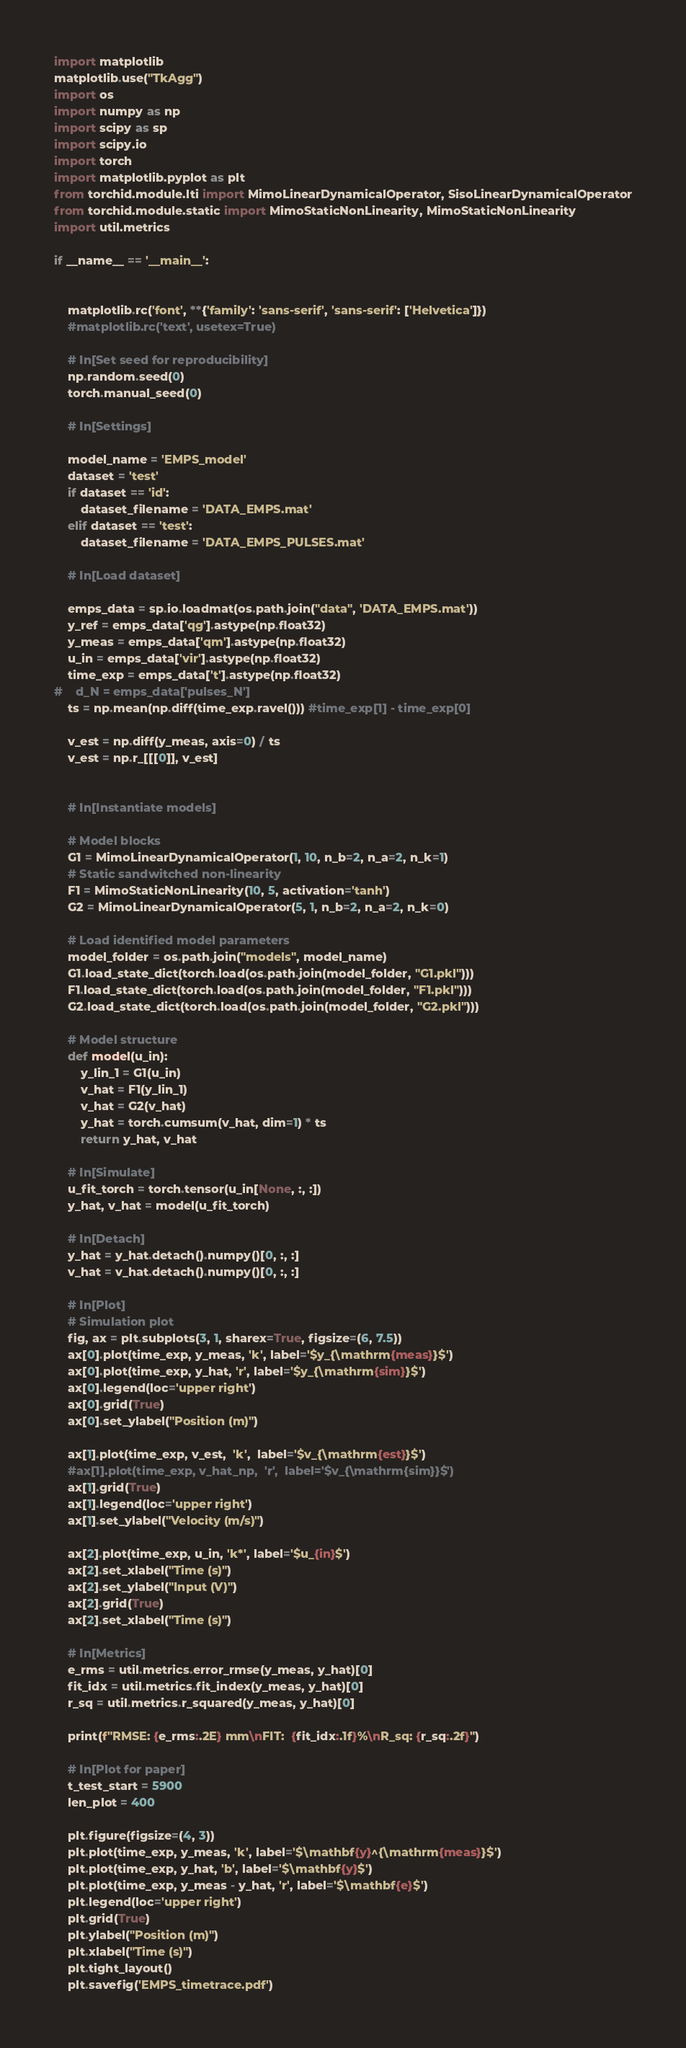Convert code to text. <code><loc_0><loc_0><loc_500><loc_500><_Python_>import matplotlib
matplotlib.use("TkAgg")
import os
import numpy as np
import scipy as sp
import scipy.io
import torch
import matplotlib.pyplot as plt
from torchid.module.lti import MimoLinearDynamicalOperator, SisoLinearDynamicalOperator
from torchid.module.static import MimoStaticNonLinearity, MimoStaticNonLinearity
import util.metrics

if __name__ == '__main__':


    matplotlib.rc('font', **{'family': 'sans-serif', 'sans-serif': ['Helvetica']})
    #matplotlib.rc('text', usetex=True)

    # In[Set seed for reproducibility]
    np.random.seed(0)
    torch.manual_seed(0)

    # In[Settings]

    model_name = 'EMPS_model'
    dataset = 'test'
    if dataset == 'id':
        dataset_filename = 'DATA_EMPS.mat'
    elif dataset == 'test':
        dataset_filename = 'DATA_EMPS_PULSES.mat'

    # In[Load dataset]

    emps_data = sp.io.loadmat(os.path.join("data", 'DATA_EMPS.mat'))
    y_ref = emps_data['qg'].astype(np.float32)
    y_meas = emps_data['qm'].astype(np.float32)
    u_in = emps_data['vir'].astype(np.float32)
    time_exp = emps_data['t'].astype(np.float32)
#    d_N = emps_data['pulses_N']
    ts = np.mean(np.diff(time_exp.ravel())) #time_exp[1] - time_exp[0]

    v_est = np.diff(y_meas, axis=0) / ts
    v_est = np.r_[[[0]], v_est]


    # In[Instantiate models]

    # Model blocks
    G1 = MimoLinearDynamicalOperator(1, 10, n_b=2, n_a=2, n_k=1)
    # Static sandwitched non-linearity
    F1 = MimoStaticNonLinearity(10, 5, activation='tanh')
    G2 = MimoLinearDynamicalOperator(5, 1, n_b=2, n_a=2, n_k=0)

    # Load identified model parameters
    model_folder = os.path.join("models", model_name)
    G1.load_state_dict(torch.load(os.path.join(model_folder, "G1.pkl")))
    F1.load_state_dict(torch.load(os.path.join(model_folder, "F1.pkl")))
    G2.load_state_dict(torch.load(os.path.join(model_folder, "G2.pkl")))

    # Model structure
    def model(u_in):
        y_lin_1 = G1(u_in)
        v_hat = F1(y_lin_1)
        v_hat = G2(v_hat)
        y_hat = torch.cumsum(v_hat, dim=1) * ts
        return y_hat, v_hat

    # In[Simulate]
    u_fit_torch = torch.tensor(u_in[None, :, :])
    y_hat, v_hat = model(u_fit_torch)

    # In[Detach]
    y_hat = y_hat.detach().numpy()[0, :, :]
    v_hat = v_hat.detach().numpy()[0, :, :]

    # In[Plot]
    # Simulation plot
    fig, ax = plt.subplots(3, 1, sharex=True, figsize=(6, 7.5))
    ax[0].plot(time_exp, y_meas, 'k', label='$y_{\mathrm{meas}}$')
    ax[0].plot(time_exp, y_hat, 'r', label='$y_{\mathrm{sim}}$')
    ax[0].legend(loc='upper right')
    ax[0].grid(True)
    ax[0].set_ylabel("Position (m)")

    ax[1].plot(time_exp, v_est,  'k',  label='$v_{\mathrm{est}}$')
    #ax[1].plot(time_exp, v_hat_np,  'r',  label='$v_{\mathrm{sim}}$')
    ax[1].grid(True)
    ax[1].legend(loc='upper right')
    ax[1].set_ylabel("Velocity (m/s)")

    ax[2].plot(time_exp, u_in, 'k*', label='$u_{in}$')
    ax[2].set_xlabel("Time (s)")
    ax[2].set_ylabel("Input (V)")
    ax[2].grid(True)
    ax[2].set_xlabel("Time (s)")

    # In[Metrics]
    e_rms = util.metrics.error_rmse(y_meas, y_hat)[0]
    fit_idx = util.metrics.fit_index(y_meas, y_hat)[0]
    r_sq = util.metrics.r_squared(y_meas, y_hat)[0]

    print(f"RMSE: {e_rms:.2E} mm\nFIT:  {fit_idx:.1f}%\nR_sq: {r_sq:.2f}")

    # In[Plot for paper]
    t_test_start = 5900
    len_plot = 400

    plt.figure(figsize=(4, 3))
    plt.plot(time_exp, y_meas, 'k', label='$\mathbf{y}^{\mathrm{meas}}$')
    plt.plot(time_exp, y_hat, 'b', label='$\mathbf{y}$')
    plt.plot(time_exp, y_meas - y_hat, 'r', label='$\mathbf{e}$')
    plt.legend(loc='upper right')
    plt.grid(True)
    plt.ylabel("Position (m)")
    plt.xlabel("Time (s)")
    plt.tight_layout()
    plt.savefig('EMPS_timetrace.pdf')

</code> 